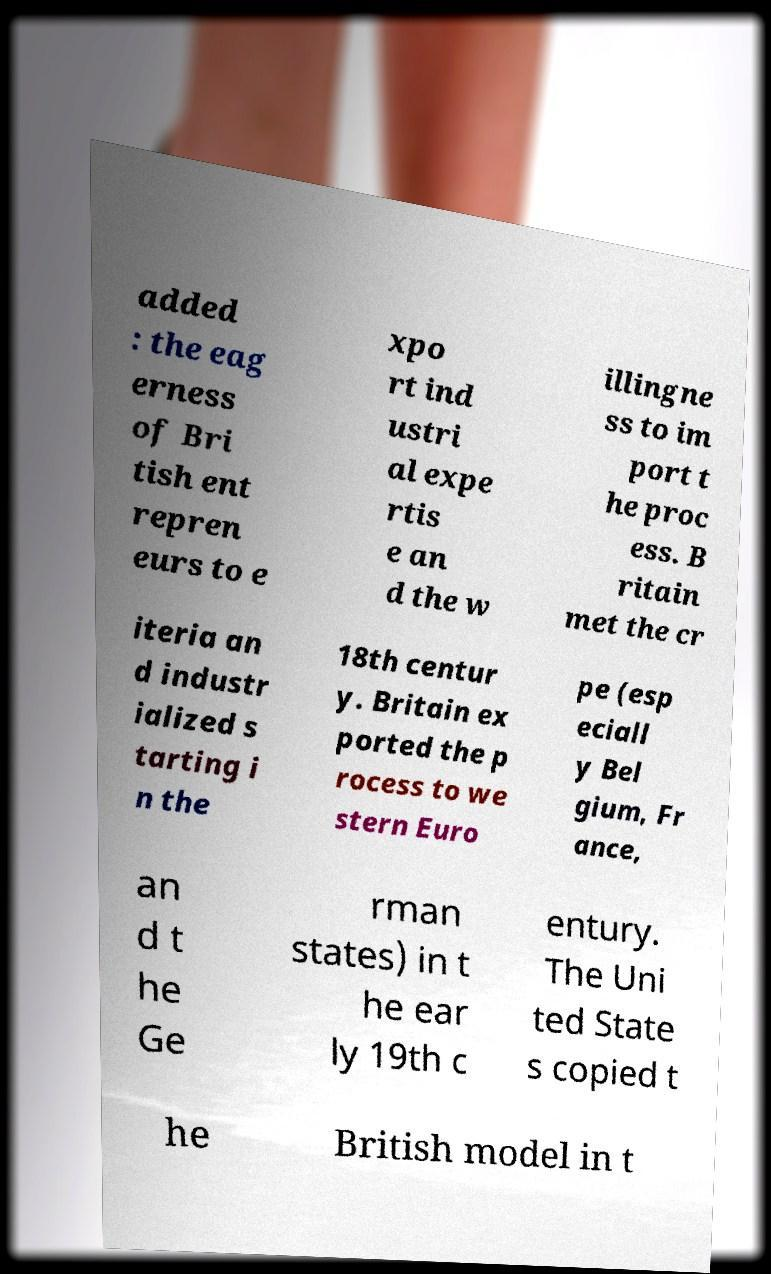Please identify and transcribe the text found in this image. added : the eag erness of Bri tish ent repren eurs to e xpo rt ind ustri al expe rtis e an d the w illingne ss to im port t he proc ess. B ritain met the cr iteria an d industr ialized s tarting i n the 18th centur y. Britain ex ported the p rocess to we stern Euro pe (esp eciall y Bel gium, Fr ance, an d t he Ge rman states) in t he ear ly 19th c entury. The Uni ted State s copied t he British model in t 